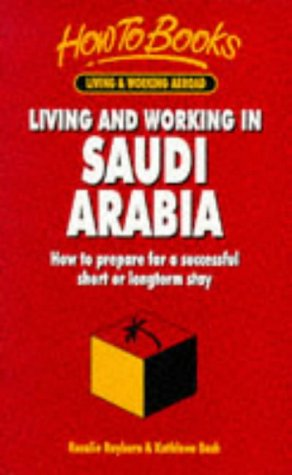What is the genre of this book? While primarily a travel genre, this book also serves as a cultural and expatriate guide for individuals considering a move to Saudi Arabia, offering practical advice for both short and long-term stays. 